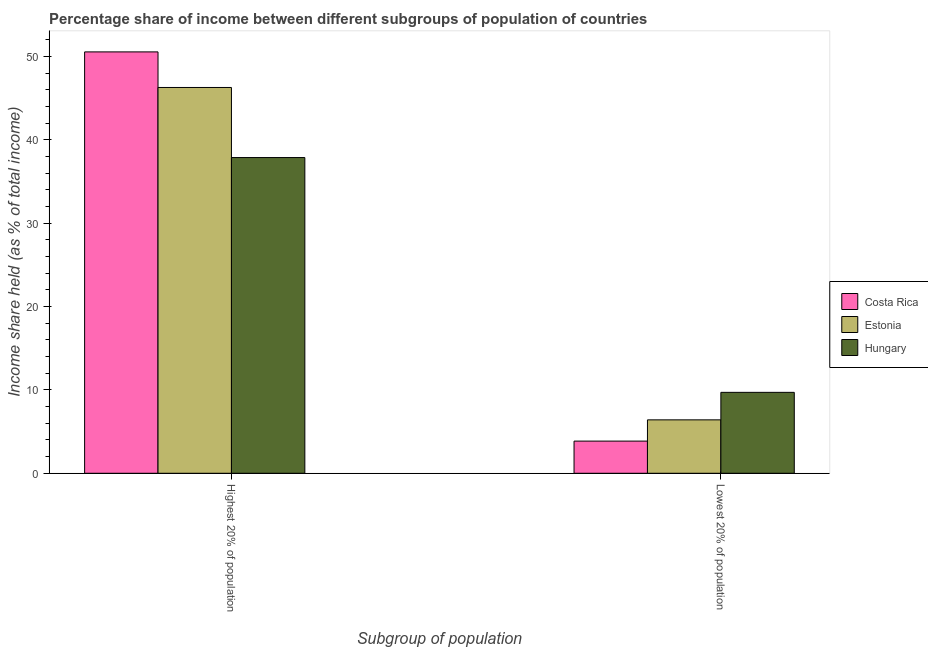How many different coloured bars are there?
Provide a succinct answer. 3. Are the number of bars per tick equal to the number of legend labels?
Offer a very short reply. Yes. Are the number of bars on each tick of the X-axis equal?
Ensure brevity in your answer.  Yes. How many bars are there on the 1st tick from the right?
Ensure brevity in your answer.  3. What is the label of the 1st group of bars from the left?
Your answer should be very brief. Highest 20% of population. What is the income share held by highest 20% of the population in Hungary?
Provide a succinct answer. 37.89. Across all countries, what is the maximum income share held by lowest 20% of the population?
Your response must be concise. 9.71. Across all countries, what is the minimum income share held by highest 20% of the population?
Your answer should be very brief. 37.89. In which country was the income share held by lowest 20% of the population maximum?
Offer a very short reply. Hungary. In which country was the income share held by lowest 20% of the population minimum?
Keep it short and to the point. Costa Rica. What is the total income share held by highest 20% of the population in the graph?
Your answer should be very brief. 134.76. What is the difference between the income share held by lowest 20% of the population in Costa Rica and that in Hungary?
Your response must be concise. -5.85. What is the difference between the income share held by highest 20% of the population in Hungary and the income share held by lowest 20% of the population in Costa Rica?
Keep it short and to the point. 34.03. What is the average income share held by lowest 20% of the population per country?
Offer a very short reply. 6.66. What is the difference between the income share held by lowest 20% of the population and income share held by highest 20% of the population in Costa Rica?
Provide a succinct answer. -46.71. In how many countries, is the income share held by highest 20% of the population greater than 34 %?
Keep it short and to the point. 3. What is the ratio of the income share held by lowest 20% of the population in Hungary to that in Costa Rica?
Your response must be concise. 2.52. In how many countries, is the income share held by highest 20% of the population greater than the average income share held by highest 20% of the population taken over all countries?
Your answer should be compact. 2. What does the 2nd bar from the left in Lowest 20% of population represents?
Offer a very short reply. Estonia. What does the 1st bar from the right in Highest 20% of population represents?
Keep it short and to the point. Hungary. How many countries are there in the graph?
Keep it short and to the point. 3. Does the graph contain any zero values?
Offer a very short reply. No. Does the graph contain grids?
Provide a succinct answer. No. Where does the legend appear in the graph?
Keep it short and to the point. Center right. How many legend labels are there?
Offer a terse response. 3. How are the legend labels stacked?
Give a very brief answer. Vertical. What is the title of the graph?
Ensure brevity in your answer.  Percentage share of income between different subgroups of population of countries. Does "Tonga" appear as one of the legend labels in the graph?
Offer a very short reply. No. What is the label or title of the X-axis?
Your answer should be very brief. Subgroup of population. What is the label or title of the Y-axis?
Offer a very short reply. Income share held (as % of total income). What is the Income share held (as % of total income) of Costa Rica in Highest 20% of population?
Your response must be concise. 50.57. What is the Income share held (as % of total income) of Estonia in Highest 20% of population?
Ensure brevity in your answer.  46.3. What is the Income share held (as % of total income) in Hungary in Highest 20% of population?
Keep it short and to the point. 37.89. What is the Income share held (as % of total income) of Costa Rica in Lowest 20% of population?
Ensure brevity in your answer.  3.86. What is the Income share held (as % of total income) in Estonia in Lowest 20% of population?
Your answer should be compact. 6.41. What is the Income share held (as % of total income) of Hungary in Lowest 20% of population?
Make the answer very short. 9.71. Across all Subgroup of population, what is the maximum Income share held (as % of total income) in Costa Rica?
Ensure brevity in your answer.  50.57. Across all Subgroup of population, what is the maximum Income share held (as % of total income) of Estonia?
Your answer should be very brief. 46.3. Across all Subgroup of population, what is the maximum Income share held (as % of total income) in Hungary?
Provide a succinct answer. 37.89. Across all Subgroup of population, what is the minimum Income share held (as % of total income) in Costa Rica?
Give a very brief answer. 3.86. Across all Subgroup of population, what is the minimum Income share held (as % of total income) in Estonia?
Offer a very short reply. 6.41. Across all Subgroup of population, what is the minimum Income share held (as % of total income) of Hungary?
Provide a succinct answer. 9.71. What is the total Income share held (as % of total income) in Costa Rica in the graph?
Provide a short and direct response. 54.43. What is the total Income share held (as % of total income) in Estonia in the graph?
Provide a short and direct response. 52.71. What is the total Income share held (as % of total income) of Hungary in the graph?
Offer a terse response. 47.6. What is the difference between the Income share held (as % of total income) of Costa Rica in Highest 20% of population and that in Lowest 20% of population?
Keep it short and to the point. 46.71. What is the difference between the Income share held (as % of total income) of Estonia in Highest 20% of population and that in Lowest 20% of population?
Provide a succinct answer. 39.89. What is the difference between the Income share held (as % of total income) of Hungary in Highest 20% of population and that in Lowest 20% of population?
Provide a short and direct response. 28.18. What is the difference between the Income share held (as % of total income) of Costa Rica in Highest 20% of population and the Income share held (as % of total income) of Estonia in Lowest 20% of population?
Your answer should be compact. 44.16. What is the difference between the Income share held (as % of total income) of Costa Rica in Highest 20% of population and the Income share held (as % of total income) of Hungary in Lowest 20% of population?
Offer a very short reply. 40.86. What is the difference between the Income share held (as % of total income) in Estonia in Highest 20% of population and the Income share held (as % of total income) in Hungary in Lowest 20% of population?
Give a very brief answer. 36.59. What is the average Income share held (as % of total income) of Costa Rica per Subgroup of population?
Offer a very short reply. 27.21. What is the average Income share held (as % of total income) in Estonia per Subgroup of population?
Give a very brief answer. 26.36. What is the average Income share held (as % of total income) in Hungary per Subgroup of population?
Your response must be concise. 23.8. What is the difference between the Income share held (as % of total income) in Costa Rica and Income share held (as % of total income) in Estonia in Highest 20% of population?
Give a very brief answer. 4.27. What is the difference between the Income share held (as % of total income) in Costa Rica and Income share held (as % of total income) in Hungary in Highest 20% of population?
Offer a terse response. 12.68. What is the difference between the Income share held (as % of total income) of Estonia and Income share held (as % of total income) of Hungary in Highest 20% of population?
Make the answer very short. 8.41. What is the difference between the Income share held (as % of total income) of Costa Rica and Income share held (as % of total income) of Estonia in Lowest 20% of population?
Your answer should be very brief. -2.55. What is the difference between the Income share held (as % of total income) in Costa Rica and Income share held (as % of total income) in Hungary in Lowest 20% of population?
Ensure brevity in your answer.  -5.85. What is the ratio of the Income share held (as % of total income) of Costa Rica in Highest 20% of population to that in Lowest 20% of population?
Your response must be concise. 13.1. What is the ratio of the Income share held (as % of total income) of Estonia in Highest 20% of population to that in Lowest 20% of population?
Make the answer very short. 7.22. What is the ratio of the Income share held (as % of total income) of Hungary in Highest 20% of population to that in Lowest 20% of population?
Your response must be concise. 3.9. What is the difference between the highest and the second highest Income share held (as % of total income) in Costa Rica?
Offer a very short reply. 46.71. What is the difference between the highest and the second highest Income share held (as % of total income) of Estonia?
Make the answer very short. 39.89. What is the difference between the highest and the second highest Income share held (as % of total income) of Hungary?
Keep it short and to the point. 28.18. What is the difference between the highest and the lowest Income share held (as % of total income) in Costa Rica?
Make the answer very short. 46.71. What is the difference between the highest and the lowest Income share held (as % of total income) of Estonia?
Your response must be concise. 39.89. What is the difference between the highest and the lowest Income share held (as % of total income) of Hungary?
Ensure brevity in your answer.  28.18. 